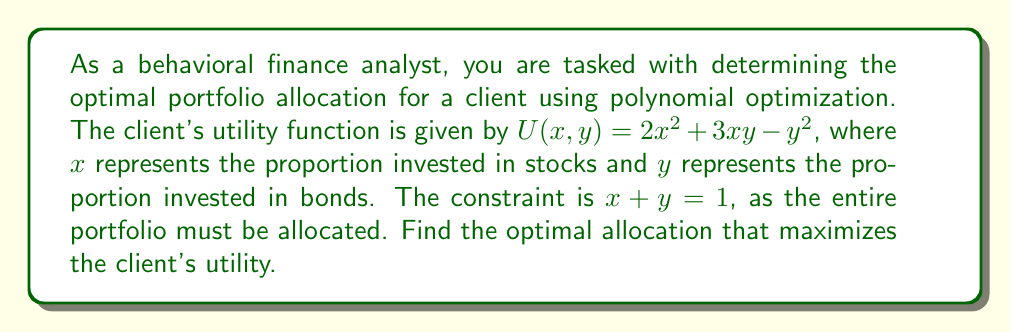Solve this math problem. 1. We need to maximize $U(x, y) = 2x^2 + 3xy - y^2$ subject to the constraint $x + y = 1$.

2. Use the constraint to express $y$ in terms of $x$:
   $y = 1 - x$

3. Substitute this into the utility function:
   $U(x) = 2x^2 + 3x(1-x) - (1-x)^2$
   $= 2x^2 + 3x - 3x^2 - (1 - 2x + x^2)$
   $= 2x^2 + 3x - 3x^2 - 1 + 2x - x^2$
   $= -2x^2 + 5x - 1$

4. To find the maximum, differentiate $U(x)$ and set it to zero:
   $\frac{dU}{dx} = -4x + 5 = 0$

5. Solve for $x$:
   $-4x = -5$
   $x = \frac{5}{4} = 1.25$

6. However, $x$ must be between 0 and 1. Since the function is quadratic and opens downward, the maximum within our constraints will be at $x = 1$.

7. Calculate $y$:
   $y = 1 - x = 1 - 1 = 0$

8. Therefore, the optimal allocation is 100% in stocks $(x = 1)$ and 0% in bonds $(y = 0)$.
Answer: 100% stocks, 0% bonds 